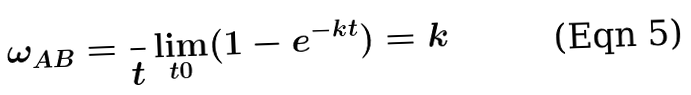Convert formula to latex. <formula><loc_0><loc_0><loc_500><loc_500>\omega _ { A B } = \frac { } { t } \lim _ { t 0 } ( 1 - e ^ { - k t } ) = k</formula> 